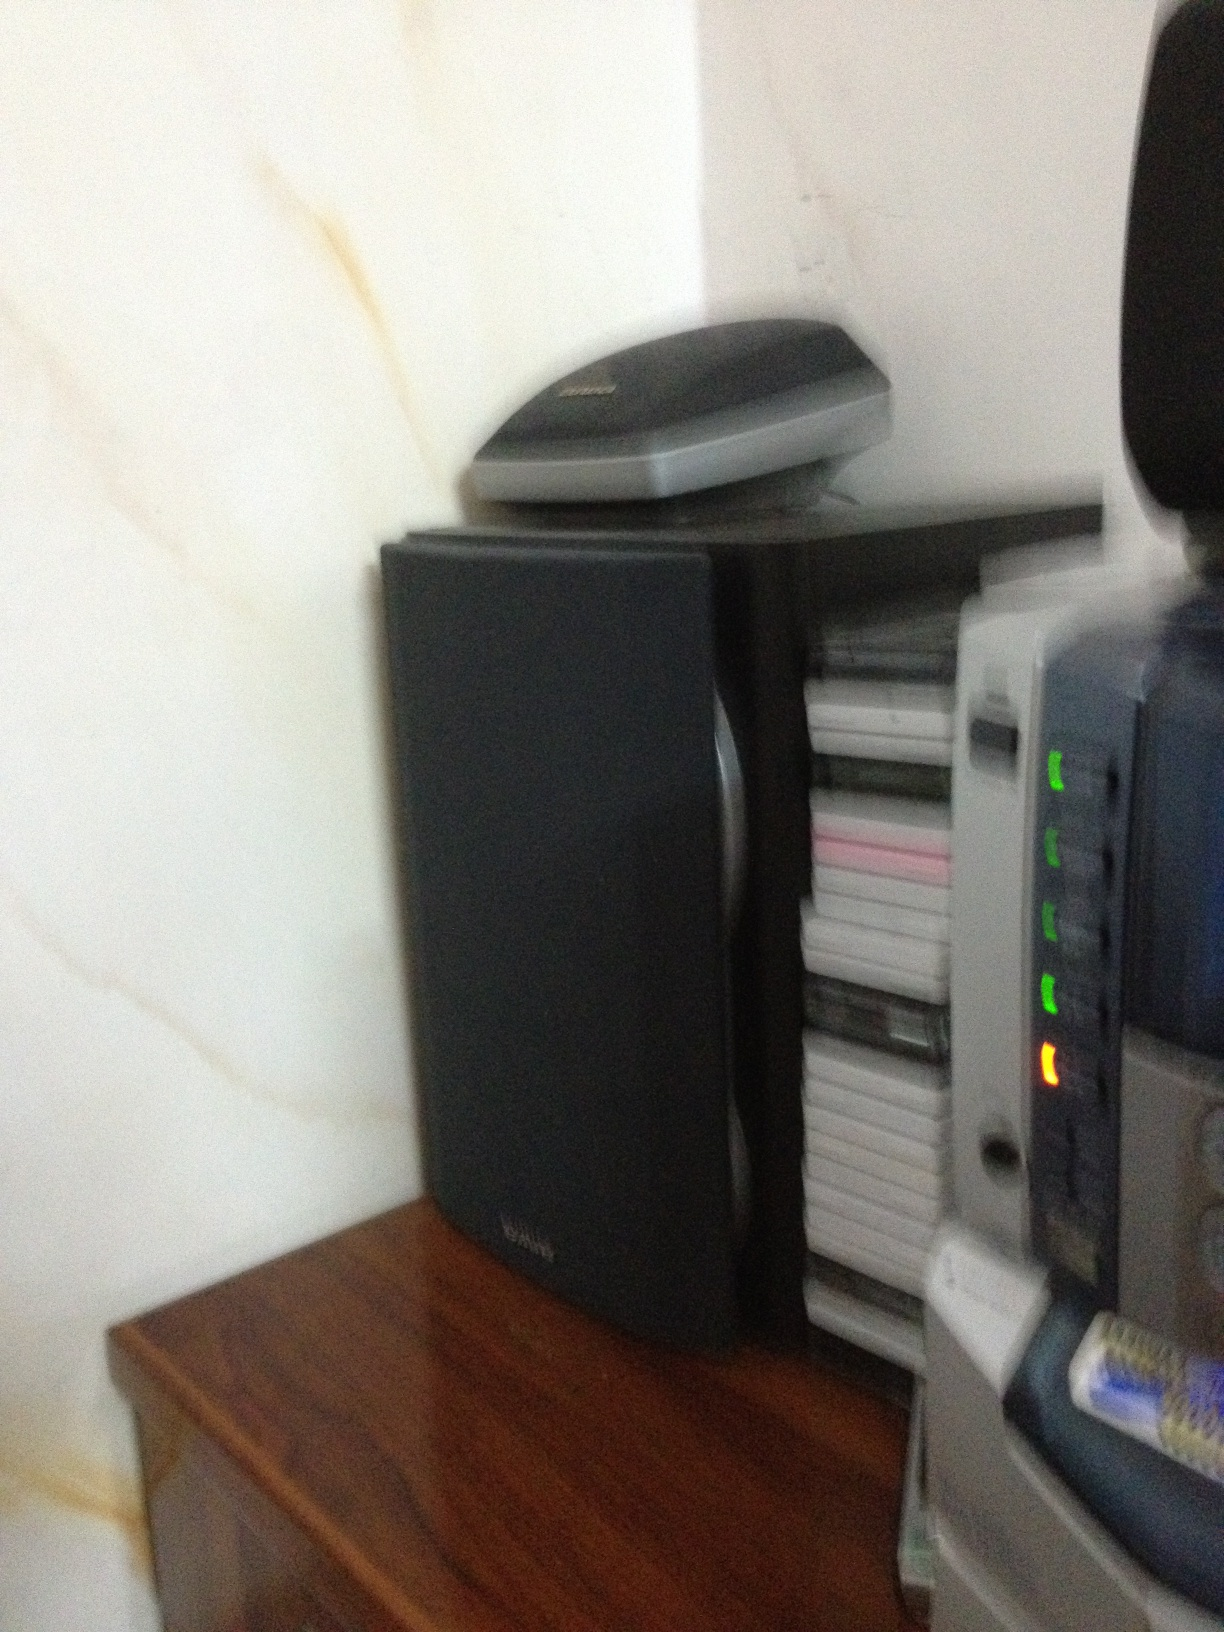What kind of devices are shown in this image? The image displays several electronic devices. Among them, there is a speaker, what seems to be a scanner, and possibly a stack of CDs or DVDs. 